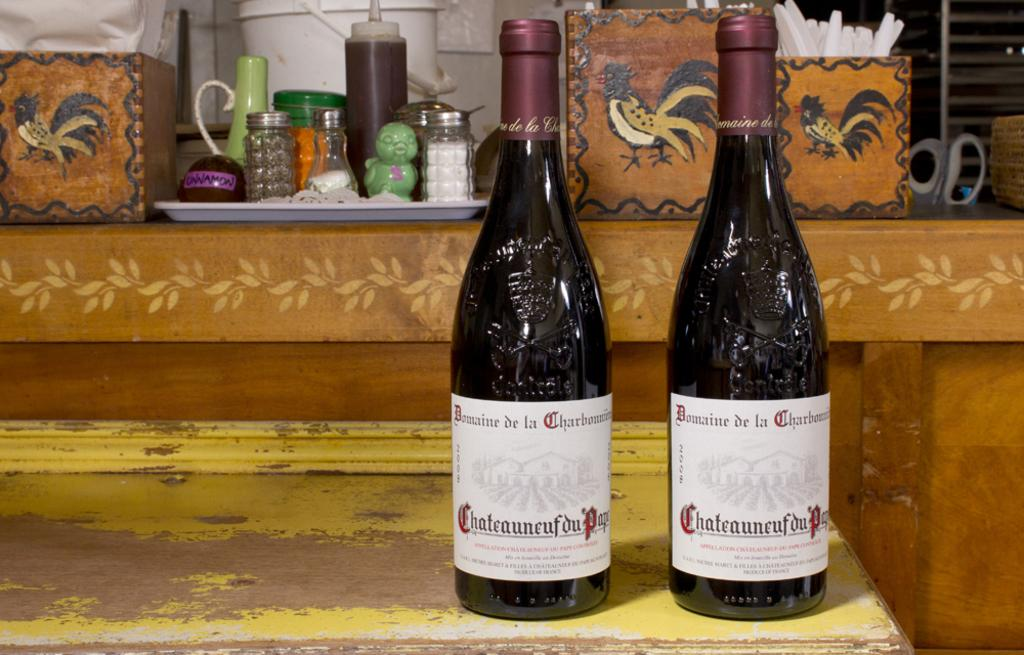<image>
Summarize the visual content of the image. Two bottles of wine with the word Bomaine on it. 